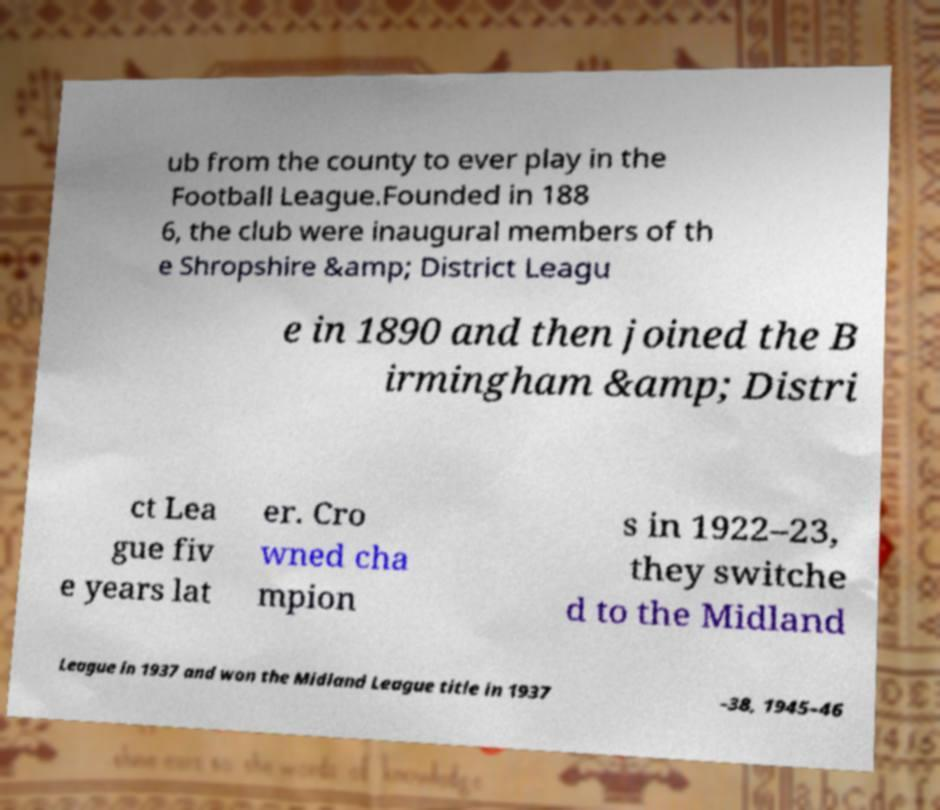Can you read and provide the text displayed in the image?This photo seems to have some interesting text. Can you extract and type it out for me? ub from the county to ever play in the Football League.Founded in 188 6, the club were inaugural members of th e Shropshire &amp; District Leagu e in 1890 and then joined the B irmingham &amp; Distri ct Lea gue fiv e years lat er. Cro wned cha mpion s in 1922–23, they switche d to the Midland League in 1937 and won the Midland League title in 1937 –38, 1945–46 